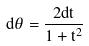Convert formula to latex. <formula><loc_0><loc_0><loc_500><loc_500>d \theta = \frac { 2 d t } { 1 + t ^ { 2 } }</formula> 